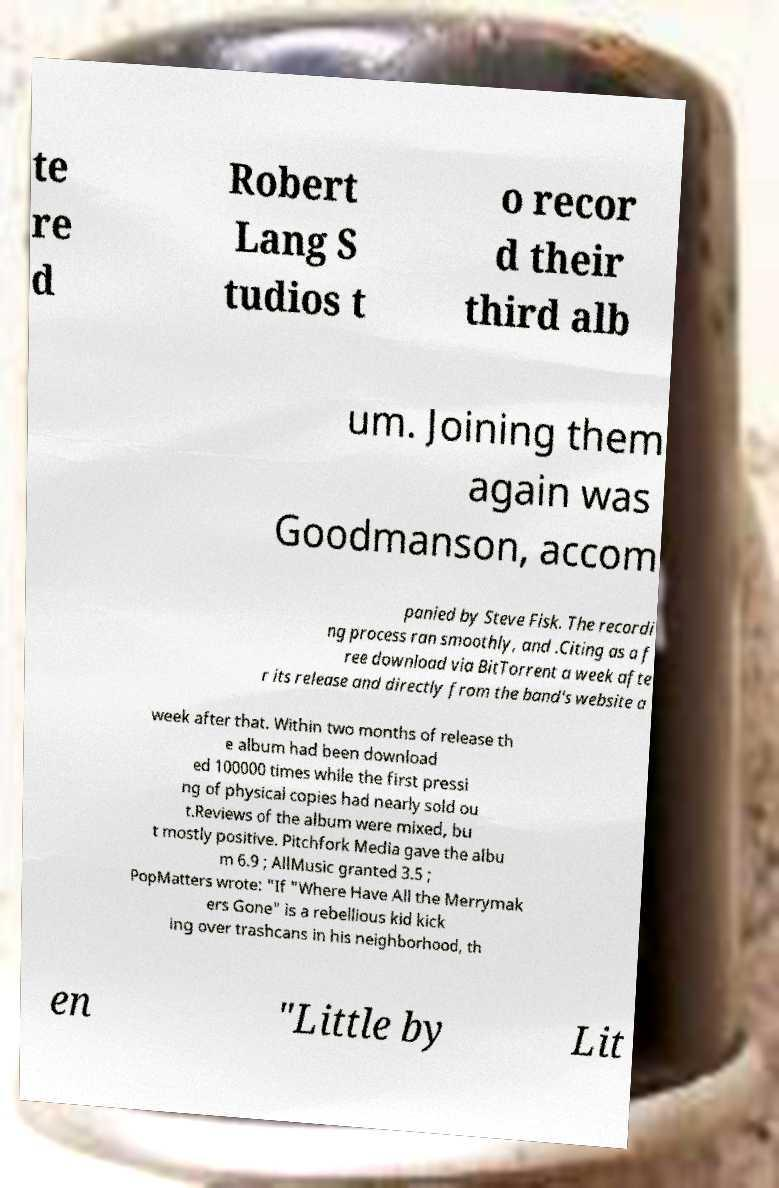For documentation purposes, I need the text within this image transcribed. Could you provide that? te re d Robert Lang S tudios t o recor d their third alb um. Joining them again was Goodmanson, accom panied by Steve Fisk. The recordi ng process ran smoothly, and .Citing as a f ree download via BitTorrent a week afte r its release and directly from the band's website a week after that. Within two months of release th e album had been download ed 100000 times while the first pressi ng of physical copies had nearly sold ou t.Reviews of the album were mixed, bu t mostly positive. Pitchfork Media gave the albu m 6.9 ; AllMusic granted 3.5 ; PopMatters wrote: "If "Where Have All the Merrymak ers Gone" is a rebellious kid kick ing over trashcans in his neighborhood, th en "Little by Lit 